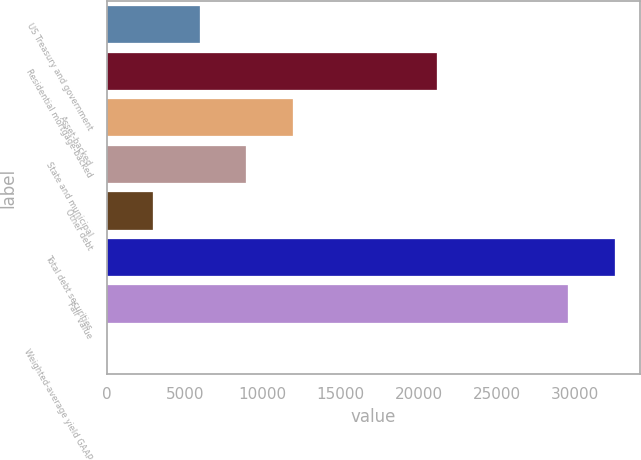<chart> <loc_0><loc_0><loc_500><loc_500><bar_chart><fcel>US Treasury and government<fcel>Residential mortgage-backed<fcel>Asset-backed<fcel>State and municipal<fcel>Other debt<fcel>Total debt securities<fcel>Fair value<fcel>Weighted-average yield GAAP<nl><fcel>5969.93<fcel>21147<fcel>11934.5<fcel>8952.19<fcel>2987.67<fcel>32543.3<fcel>29561<fcel>5.41<nl></chart> 